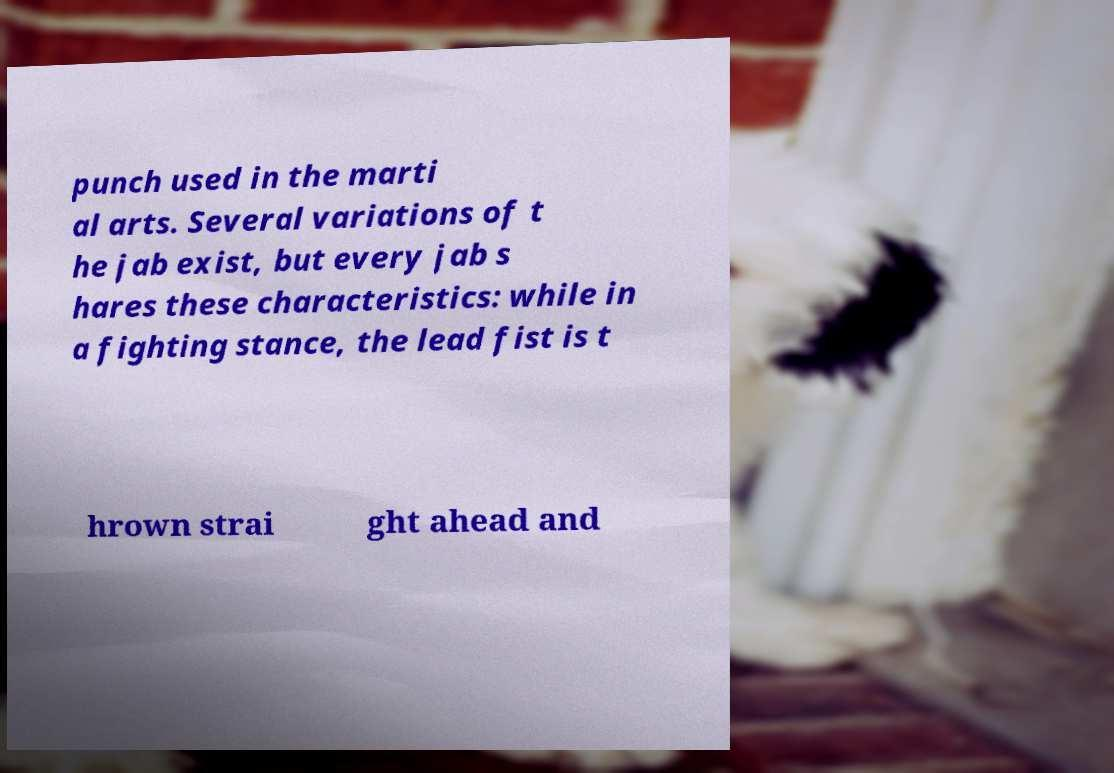Could you assist in decoding the text presented in this image and type it out clearly? punch used in the marti al arts. Several variations of t he jab exist, but every jab s hares these characteristics: while in a fighting stance, the lead fist is t hrown strai ght ahead and 